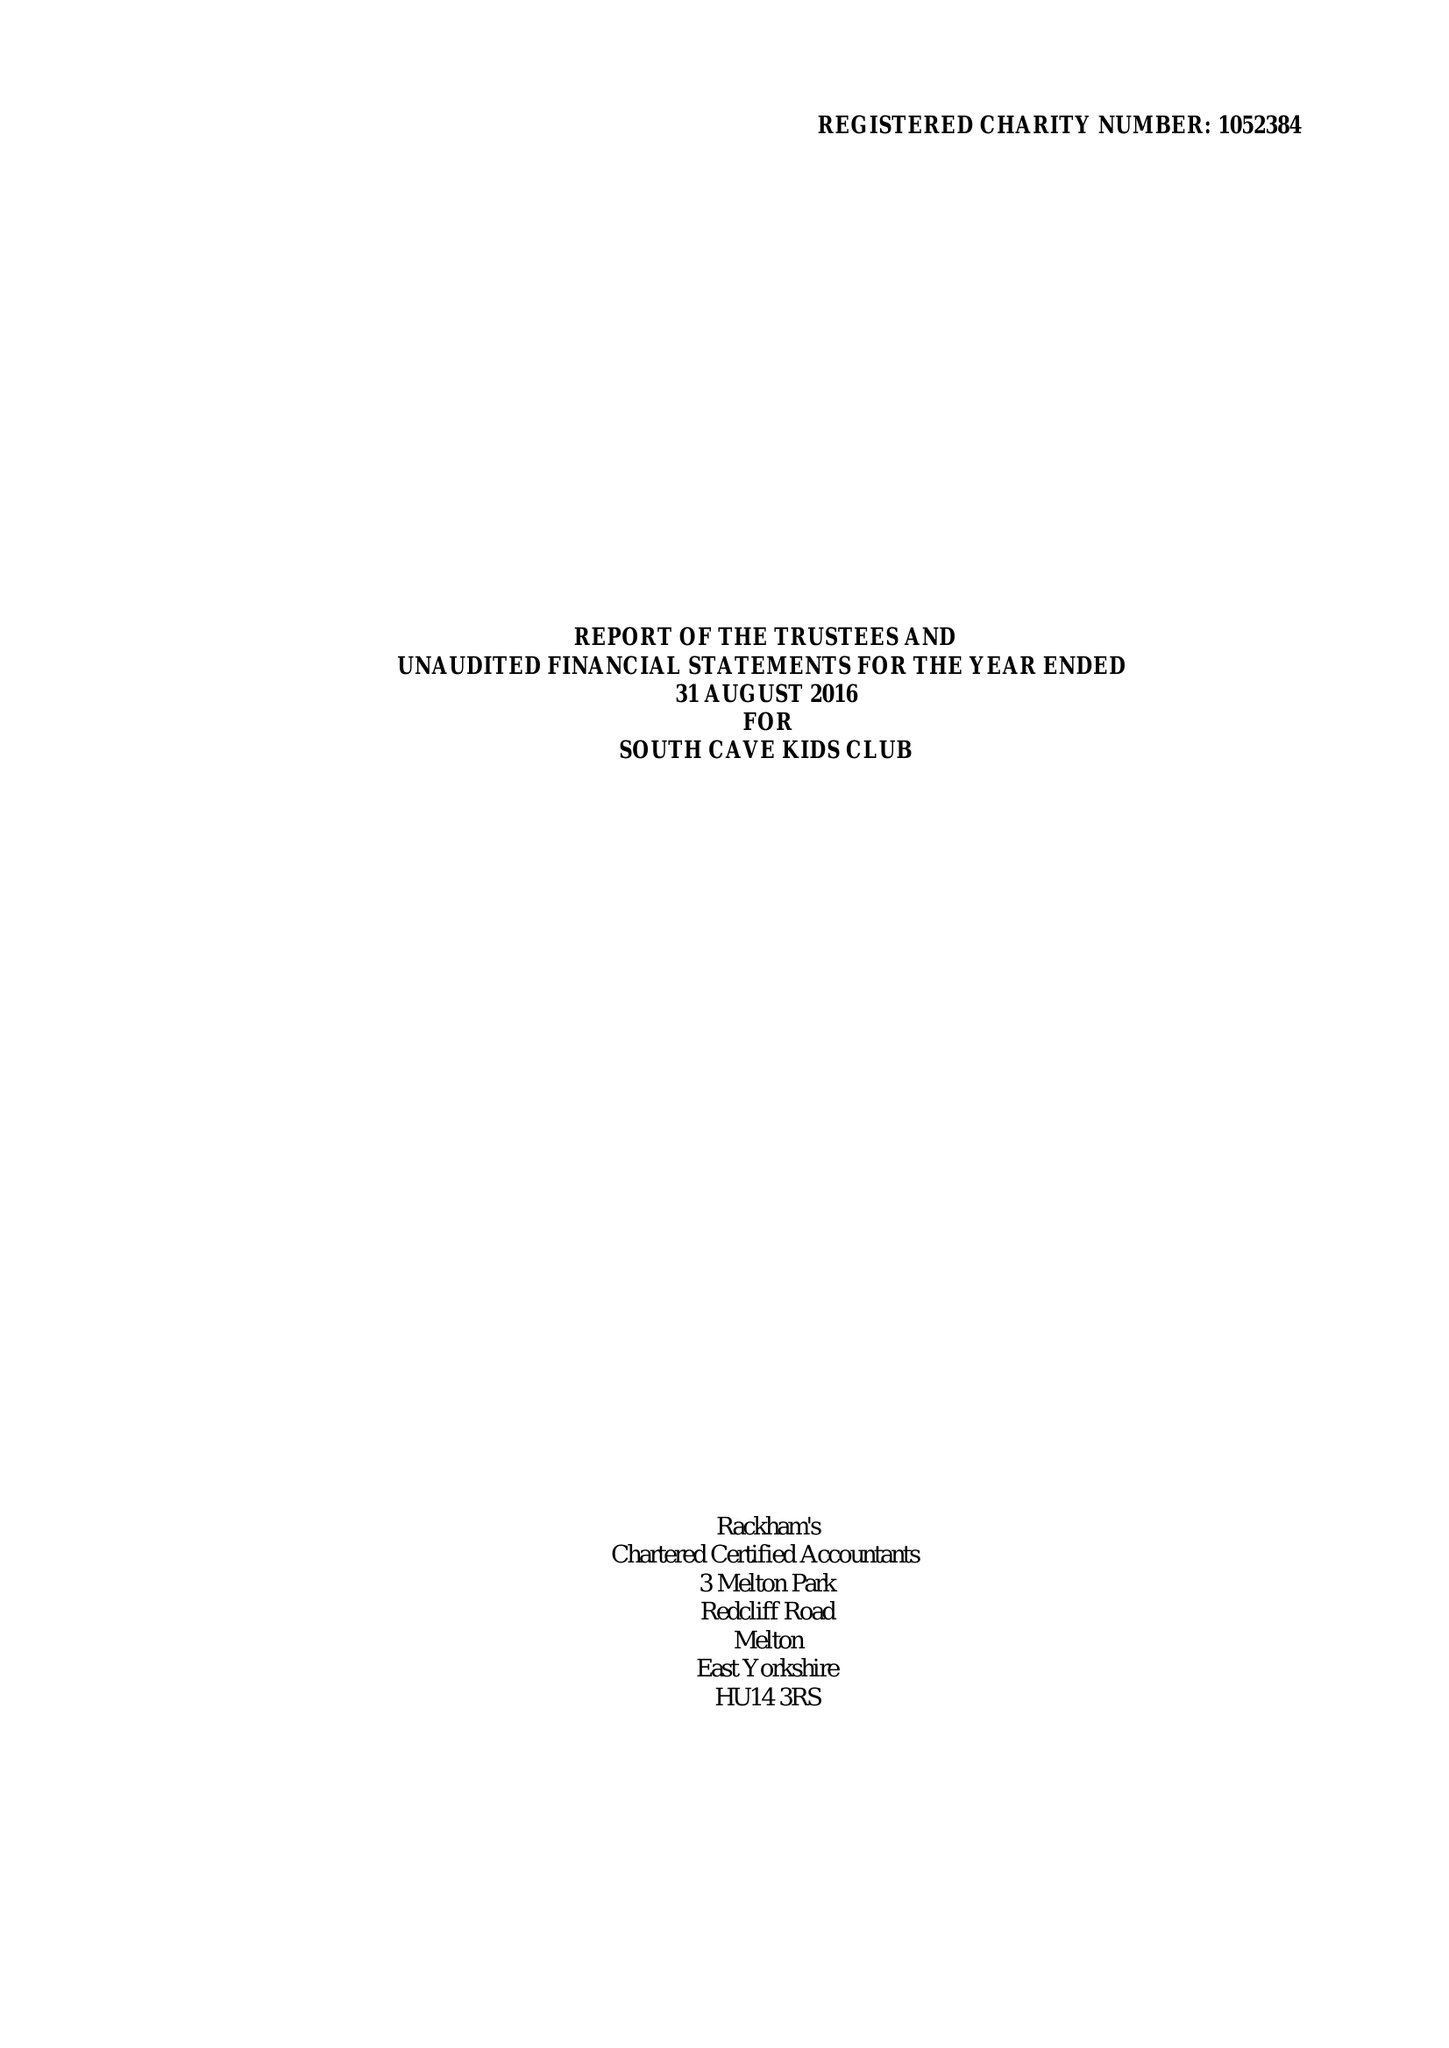What is the value for the address__postcode?
Answer the question using a single word or phrase. HU15 2EP 